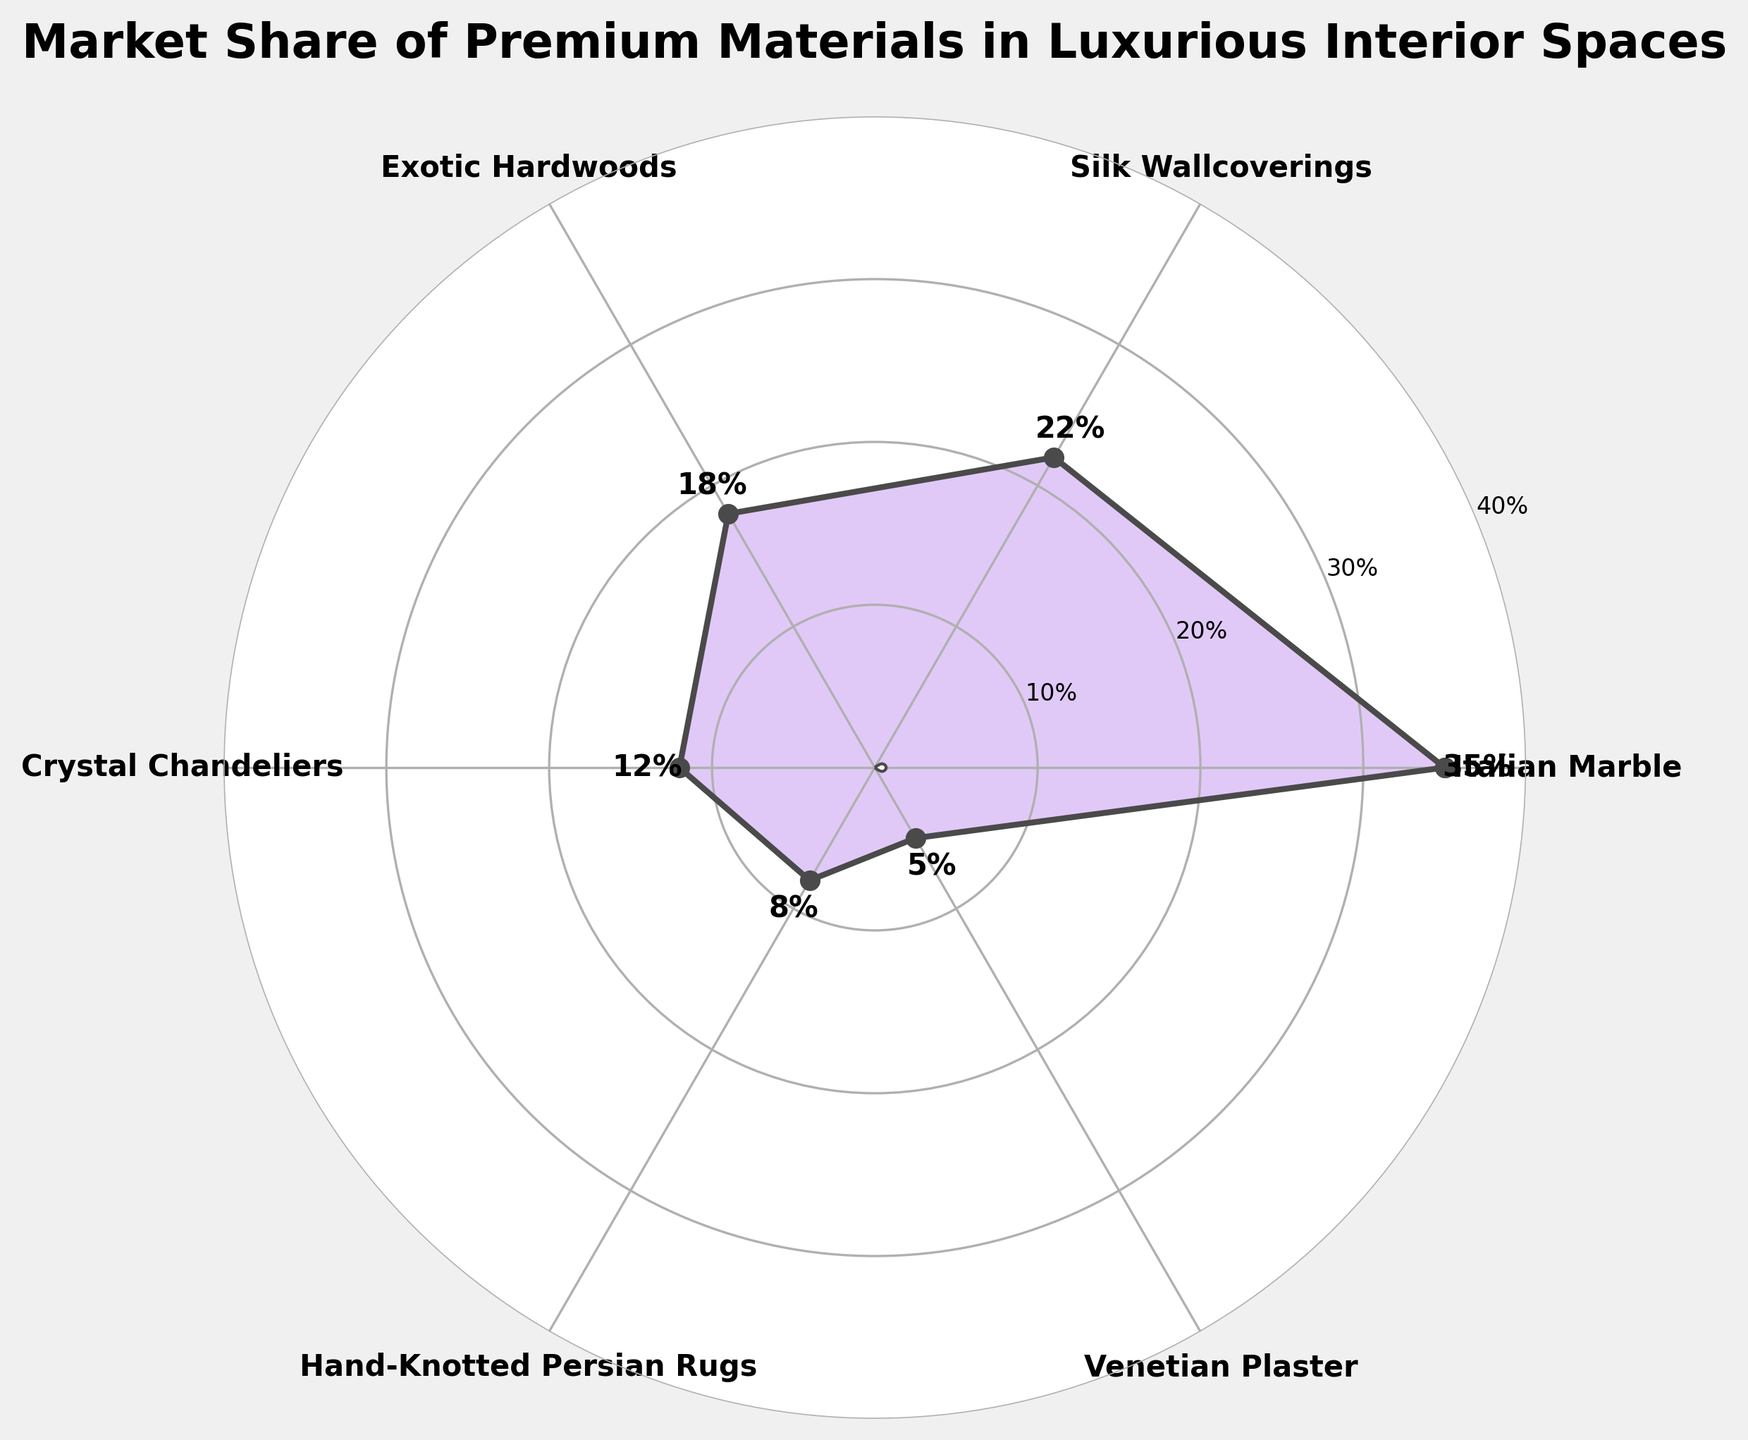What material has the highest market share? The material with the highest market share will be the one with the highest percentage value on the chart. According to the chart, the material with the highest market share is Italian Marble.
Answer: Italian Marble Which material has the lowest market share, and what is its percentage? The material with the lowest market share will be the one with the smallest percentage value on the chart. From the visual data, the material with the lowest market share is Venetian Plaster at 5%.
Answer: Venetian Plaster, 5% What is the combined market share of Silk Wallcoverings and Crystal Chandeliers? To find the combined market share, sum up the individual market shares of Silk Wallcoverings and Crystal Chandeliers. Silk Wallcoverings has a 22% market share, and Crystal Chandeliers has a 12% market share. Adding these together gives 22% + 12% = 34%.
Answer: 34% How much more market share does Italian Marble have compared to Exotic Hardwoods? To determine the difference in market share between Italian Marble and Exotic Hardwoods, subtract the market share of Exotic Hardwoods from that of Italian Marble. Italian Marble has a 35% share, and Exotic Hardwoods have an 18% share. So, 35% - 18% = 17%.
Answer: 17% Which material has a market share closest to 10%? The material with a market share closest to 10% can be identified by looking at the percentages and finding the closest one. Crystal Chandeliers have a market share of 12%, which is closest to 10%.
Answer: Crystal Chandeliers How many materials have a market share of at least 20%? Count the number of materials that have a market share of 20% or higher. From the chart, only Italian Marble (35%) and Silk Wallcoverings (22%) meet this criterion, i.e., 2 materials.
Answer: 2 What is the average market share of all the materials? To find the average market share, sum the market shares of all the materials and divide by the number of materials. Adding them: (35 + 22 + 18 + 12 + 8 + 5) = 100. There are 6 materials, so the average is 100/6 ≈ 16.67%.
Answer: 16.67% Which two materials combined would sum up to the highest market share? Sum up combinations of two materials' market shares to identify which pair gives the highest total. The highest sum is 35% (Italian Marble) + 22% (Silk Wallcoverings) = 57%.
Answer: Italian Marble and Silk Wallcoverings What is the total market share of all materials except for Persian Rugs? Subtract the market share of Hand-Knotted Persian Rugs from the total share of all materials. Total is 100%, and Hand-Knotted Persian Rugs is 8%, so 100% - 8% = 92%.
Answer: 92% What color is used to fill the area under the curve in the chart? Inspect the visual appearance of the filled area under the curve. The filled area under the curve is colored with a shade of purple.
Answer: Purple 